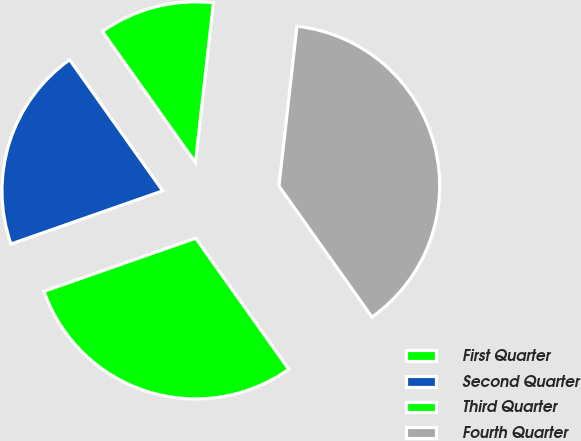<chart> <loc_0><loc_0><loc_500><loc_500><pie_chart><fcel>First Quarter<fcel>Second Quarter<fcel>Third Quarter<fcel>Fourth Quarter<nl><fcel>11.61%<fcel>20.54%<fcel>29.46%<fcel>38.39%<nl></chart> 